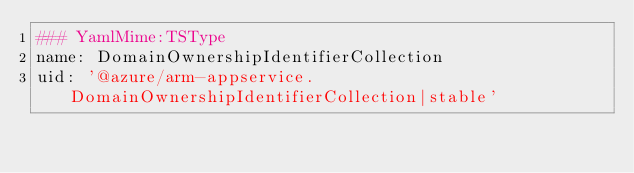Convert code to text. <code><loc_0><loc_0><loc_500><loc_500><_YAML_>### YamlMime:TSType
name: DomainOwnershipIdentifierCollection
uid: '@azure/arm-appservice.DomainOwnershipIdentifierCollection|stable'</code> 